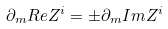Convert formula to latex. <formula><loc_0><loc_0><loc_500><loc_500>\partial _ { m } R e Z ^ { i } = \pm \partial _ { m } I m Z ^ { i }</formula> 